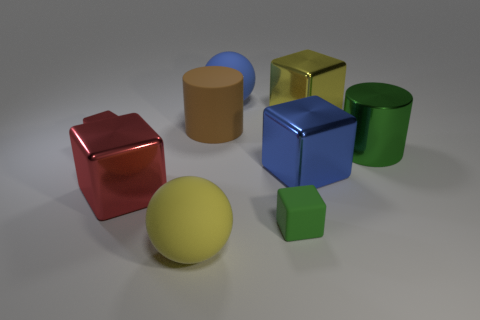The matte block has what size?
Keep it short and to the point. Small. Is there a cylinder made of the same material as the small red block?
Give a very brief answer. Yes. What size is the green rubber thing that is the same shape as the big yellow metallic object?
Give a very brief answer. Small. Are there the same number of yellow rubber balls that are on the right side of the matte block and brown cylinders?
Your answer should be compact. No. There is a green thing that is in front of the big green thing; is it the same shape as the large brown thing?
Offer a very short reply. No. The blue rubber thing has what shape?
Your response must be concise. Sphere. What is the material of the yellow object in front of the tiny object in front of the big thing that is to the right of the yellow shiny cube?
Offer a terse response. Rubber. What is the material of the tiny thing that is the same color as the shiny cylinder?
Provide a succinct answer. Rubber. What number of things are either big green matte objects or matte spheres?
Make the answer very short. 2. Is the green thing that is to the right of the matte block made of the same material as the big yellow ball?
Provide a short and direct response. No. 